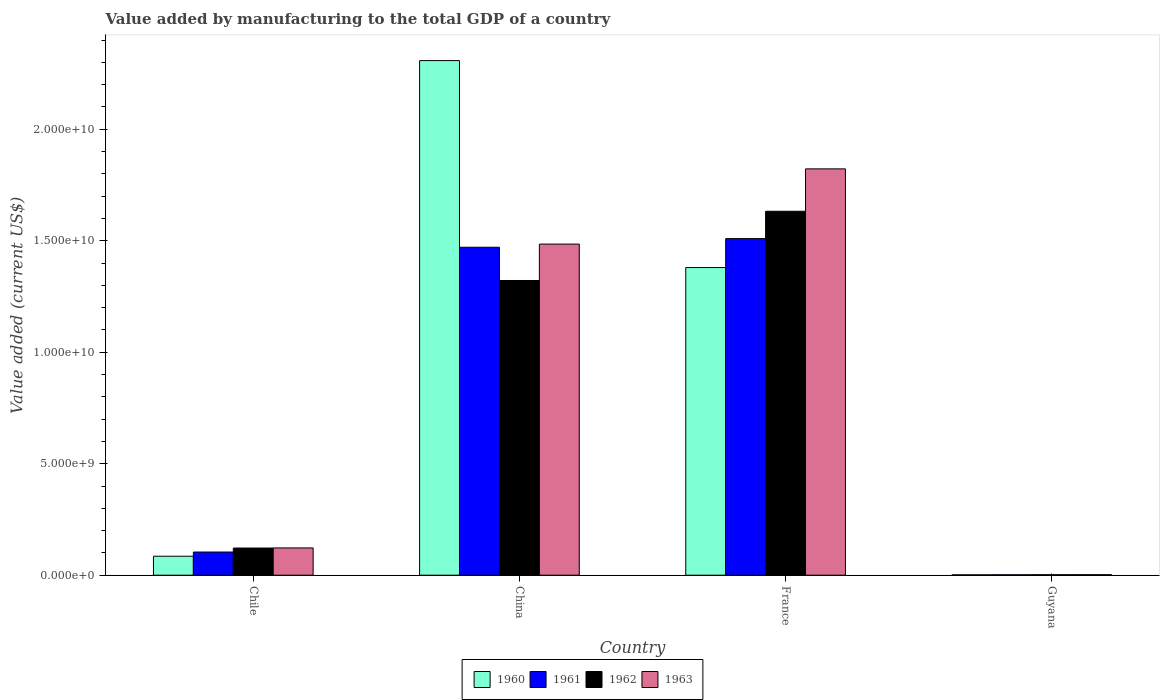How many bars are there on the 3rd tick from the left?
Your answer should be compact. 4. How many bars are there on the 1st tick from the right?
Make the answer very short. 4. In how many cases, is the number of bars for a given country not equal to the number of legend labels?
Provide a short and direct response. 0. What is the value added by manufacturing to the total GDP in 1961 in Guyana?
Keep it short and to the point. 1.84e+07. Across all countries, what is the maximum value added by manufacturing to the total GDP in 1960?
Your answer should be compact. 2.31e+1. Across all countries, what is the minimum value added by manufacturing to the total GDP in 1961?
Provide a succinct answer. 1.84e+07. In which country was the value added by manufacturing to the total GDP in 1963 minimum?
Your response must be concise. Guyana. What is the total value added by manufacturing to the total GDP in 1961 in the graph?
Offer a very short reply. 3.09e+1. What is the difference between the value added by manufacturing to the total GDP in 1962 in Chile and that in France?
Your answer should be compact. -1.51e+1. What is the difference between the value added by manufacturing to the total GDP in 1960 in France and the value added by manufacturing to the total GDP in 1962 in Guyana?
Your answer should be very brief. 1.38e+1. What is the average value added by manufacturing to the total GDP in 1963 per country?
Give a very brief answer. 8.58e+09. What is the difference between the value added by manufacturing to the total GDP of/in 1962 and value added by manufacturing to the total GDP of/in 1963 in China?
Your answer should be compact. -1.63e+09. In how many countries, is the value added by manufacturing to the total GDP in 1960 greater than 7000000000 US$?
Your answer should be very brief. 2. What is the ratio of the value added by manufacturing to the total GDP in 1962 in Chile to that in China?
Your answer should be very brief. 0.09. Is the value added by manufacturing to the total GDP in 1963 in France less than that in Guyana?
Provide a short and direct response. No. What is the difference between the highest and the second highest value added by manufacturing to the total GDP in 1960?
Ensure brevity in your answer.  1.29e+1. What is the difference between the highest and the lowest value added by manufacturing to the total GDP in 1962?
Offer a terse response. 1.63e+1. Is the sum of the value added by manufacturing to the total GDP in 1960 in Chile and France greater than the maximum value added by manufacturing to the total GDP in 1963 across all countries?
Offer a very short reply. No. What does the 4th bar from the left in China represents?
Ensure brevity in your answer.  1963. What does the 4th bar from the right in Chile represents?
Keep it short and to the point. 1960. Is it the case that in every country, the sum of the value added by manufacturing to the total GDP in 1962 and value added by manufacturing to the total GDP in 1961 is greater than the value added by manufacturing to the total GDP in 1963?
Keep it short and to the point. Yes. How many bars are there?
Offer a very short reply. 16. Are all the bars in the graph horizontal?
Give a very brief answer. No. How many countries are there in the graph?
Give a very brief answer. 4. Are the values on the major ticks of Y-axis written in scientific E-notation?
Give a very brief answer. Yes. Does the graph contain any zero values?
Your answer should be very brief. No. How are the legend labels stacked?
Offer a very short reply. Horizontal. What is the title of the graph?
Keep it short and to the point. Value added by manufacturing to the total GDP of a country. Does "1975" appear as one of the legend labels in the graph?
Keep it short and to the point. No. What is the label or title of the X-axis?
Your answer should be compact. Country. What is the label or title of the Y-axis?
Your answer should be compact. Value added (current US$). What is the Value added (current US$) in 1960 in Chile?
Offer a very short reply. 8.51e+08. What is the Value added (current US$) of 1961 in Chile?
Give a very brief answer. 1.04e+09. What is the Value added (current US$) in 1962 in Chile?
Your answer should be compact. 1.22e+09. What is the Value added (current US$) in 1963 in Chile?
Offer a very short reply. 1.22e+09. What is the Value added (current US$) in 1960 in China?
Offer a terse response. 2.31e+1. What is the Value added (current US$) of 1961 in China?
Provide a short and direct response. 1.47e+1. What is the Value added (current US$) of 1962 in China?
Offer a very short reply. 1.32e+1. What is the Value added (current US$) of 1963 in China?
Give a very brief answer. 1.49e+1. What is the Value added (current US$) in 1960 in France?
Provide a short and direct response. 1.38e+1. What is the Value added (current US$) of 1961 in France?
Give a very brief answer. 1.51e+1. What is the Value added (current US$) of 1962 in France?
Offer a terse response. 1.63e+1. What is the Value added (current US$) in 1963 in France?
Keep it short and to the point. 1.82e+1. What is the Value added (current US$) of 1960 in Guyana?
Your answer should be very brief. 1.59e+07. What is the Value added (current US$) in 1961 in Guyana?
Offer a very short reply. 1.84e+07. What is the Value added (current US$) in 1962 in Guyana?
Ensure brevity in your answer.  2.08e+07. What is the Value added (current US$) of 1963 in Guyana?
Your answer should be very brief. 2.32e+07. Across all countries, what is the maximum Value added (current US$) in 1960?
Your response must be concise. 2.31e+1. Across all countries, what is the maximum Value added (current US$) of 1961?
Keep it short and to the point. 1.51e+1. Across all countries, what is the maximum Value added (current US$) in 1962?
Provide a short and direct response. 1.63e+1. Across all countries, what is the maximum Value added (current US$) of 1963?
Ensure brevity in your answer.  1.82e+1. Across all countries, what is the minimum Value added (current US$) of 1960?
Keep it short and to the point. 1.59e+07. Across all countries, what is the minimum Value added (current US$) in 1961?
Offer a very short reply. 1.84e+07. Across all countries, what is the minimum Value added (current US$) in 1962?
Offer a very short reply. 2.08e+07. Across all countries, what is the minimum Value added (current US$) in 1963?
Keep it short and to the point. 2.32e+07. What is the total Value added (current US$) in 1960 in the graph?
Your response must be concise. 3.77e+1. What is the total Value added (current US$) of 1961 in the graph?
Your answer should be compact. 3.09e+1. What is the total Value added (current US$) of 1962 in the graph?
Offer a very short reply. 3.08e+1. What is the total Value added (current US$) in 1963 in the graph?
Provide a succinct answer. 3.43e+1. What is the difference between the Value added (current US$) in 1960 in Chile and that in China?
Make the answer very short. -2.22e+1. What is the difference between the Value added (current US$) of 1961 in Chile and that in China?
Make the answer very short. -1.37e+1. What is the difference between the Value added (current US$) in 1962 in Chile and that in China?
Offer a terse response. -1.20e+1. What is the difference between the Value added (current US$) in 1963 in Chile and that in China?
Your answer should be very brief. -1.36e+1. What is the difference between the Value added (current US$) of 1960 in Chile and that in France?
Your answer should be compact. -1.29e+1. What is the difference between the Value added (current US$) of 1961 in Chile and that in France?
Your response must be concise. -1.41e+1. What is the difference between the Value added (current US$) in 1962 in Chile and that in France?
Keep it short and to the point. -1.51e+1. What is the difference between the Value added (current US$) in 1963 in Chile and that in France?
Ensure brevity in your answer.  -1.70e+1. What is the difference between the Value added (current US$) of 1960 in Chile and that in Guyana?
Your answer should be compact. 8.35e+08. What is the difference between the Value added (current US$) in 1961 in Chile and that in Guyana?
Your answer should be compact. 1.02e+09. What is the difference between the Value added (current US$) in 1962 in Chile and that in Guyana?
Give a very brief answer. 1.20e+09. What is the difference between the Value added (current US$) in 1963 in Chile and that in Guyana?
Provide a succinct answer. 1.20e+09. What is the difference between the Value added (current US$) in 1960 in China and that in France?
Offer a terse response. 9.28e+09. What is the difference between the Value added (current US$) in 1961 in China and that in France?
Offer a terse response. -3.87e+08. What is the difference between the Value added (current US$) of 1962 in China and that in France?
Give a very brief answer. -3.11e+09. What is the difference between the Value added (current US$) in 1963 in China and that in France?
Give a very brief answer. -3.37e+09. What is the difference between the Value added (current US$) of 1960 in China and that in Guyana?
Your answer should be very brief. 2.31e+1. What is the difference between the Value added (current US$) of 1961 in China and that in Guyana?
Ensure brevity in your answer.  1.47e+1. What is the difference between the Value added (current US$) of 1962 in China and that in Guyana?
Provide a succinct answer. 1.32e+1. What is the difference between the Value added (current US$) of 1963 in China and that in Guyana?
Your answer should be very brief. 1.48e+1. What is the difference between the Value added (current US$) of 1960 in France and that in Guyana?
Offer a very short reply. 1.38e+1. What is the difference between the Value added (current US$) in 1961 in France and that in Guyana?
Offer a very short reply. 1.51e+1. What is the difference between the Value added (current US$) in 1962 in France and that in Guyana?
Your answer should be compact. 1.63e+1. What is the difference between the Value added (current US$) of 1963 in France and that in Guyana?
Your response must be concise. 1.82e+1. What is the difference between the Value added (current US$) in 1960 in Chile and the Value added (current US$) in 1961 in China?
Make the answer very short. -1.39e+1. What is the difference between the Value added (current US$) of 1960 in Chile and the Value added (current US$) of 1962 in China?
Ensure brevity in your answer.  -1.24e+1. What is the difference between the Value added (current US$) of 1960 in Chile and the Value added (current US$) of 1963 in China?
Provide a succinct answer. -1.40e+1. What is the difference between the Value added (current US$) in 1961 in Chile and the Value added (current US$) in 1962 in China?
Your answer should be compact. -1.22e+1. What is the difference between the Value added (current US$) in 1961 in Chile and the Value added (current US$) in 1963 in China?
Make the answer very short. -1.38e+1. What is the difference between the Value added (current US$) of 1962 in Chile and the Value added (current US$) of 1963 in China?
Your answer should be very brief. -1.36e+1. What is the difference between the Value added (current US$) of 1960 in Chile and the Value added (current US$) of 1961 in France?
Your response must be concise. -1.42e+1. What is the difference between the Value added (current US$) of 1960 in Chile and the Value added (current US$) of 1962 in France?
Provide a succinct answer. -1.55e+1. What is the difference between the Value added (current US$) in 1960 in Chile and the Value added (current US$) in 1963 in France?
Give a very brief answer. -1.74e+1. What is the difference between the Value added (current US$) in 1961 in Chile and the Value added (current US$) in 1962 in France?
Give a very brief answer. -1.53e+1. What is the difference between the Value added (current US$) in 1961 in Chile and the Value added (current US$) in 1963 in France?
Provide a succinct answer. -1.72e+1. What is the difference between the Value added (current US$) of 1962 in Chile and the Value added (current US$) of 1963 in France?
Give a very brief answer. -1.70e+1. What is the difference between the Value added (current US$) in 1960 in Chile and the Value added (current US$) in 1961 in Guyana?
Provide a succinct answer. 8.32e+08. What is the difference between the Value added (current US$) in 1960 in Chile and the Value added (current US$) in 1962 in Guyana?
Provide a short and direct response. 8.30e+08. What is the difference between the Value added (current US$) in 1960 in Chile and the Value added (current US$) in 1963 in Guyana?
Keep it short and to the point. 8.28e+08. What is the difference between the Value added (current US$) of 1961 in Chile and the Value added (current US$) of 1962 in Guyana?
Your answer should be compact. 1.02e+09. What is the difference between the Value added (current US$) of 1961 in Chile and the Value added (current US$) of 1963 in Guyana?
Offer a very short reply. 1.02e+09. What is the difference between the Value added (current US$) in 1962 in Chile and the Value added (current US$) in 1963 in Guyana?
Keep it short and to the point. 1.20e+09. What is the difference between the Value added (current US$) in 1960 in China and the Value added (current US$) in 1961 in France?
Your answer should be compact. 7.98e+09. What is the difference between the Value added (current US$) in 1960 in China and the Value added (current US$) in 1962 in France?
Offer a very short reply. 6.76e+09. What is the difference between the Value added (current US$) in 1960 in China and the Value added (current US$) in 1963 in France?
Keep it short and to the point. 4.86e+09. What is the difference between the Value added (current US$) of 1961 in China and the Value added (current US$) of 1962 in France?
Give a very brief answer. -1.61e+09. What is the difference between the Value added (current US$) of 1961 in China and the Value added (current US$) of 1963 in France?
Offer a terse response. -3.52e+09. What is the difference between the Value added (current US$) of 1962 in China and the Value added (current US$) of 1963 in France?
Offer a terse response. -5.01e+09. What is the difference between the Value added (current US$) of 1960 in China and the Value added (current US$) of 1961 in Guyana?
Your answer should be compact. 2.31e+1. What is the difference between the Value added (current US$) of 1960 in China and the Value added (current US$) of 1962 in Guyana?
Offer a very short reply. 2.31e+1. What is the difference between the Value added (current US$) in 1960 in China and the Value added (current US$) in 1963 in Guyana?
Provide a short and direct response. 2.31e+1. What is the difference between the Value added (current US$) in 1961 in China and the Value added (current US$) in 1962 in Guyana?
Ensure brevity in your answer.  1.47e+1. What is the difference between the Value added (current US$) of 1961 in China and the Value added (current US$) of 1963 in Guyana?
Your answer should be very brief. 1.47e+1. What is the difference between the Value added (current US$) of 1962 in China and the Value added (current US$) of 1963 in Guyana?
Your response must be concise. 1.32e+1. What is the difference between the Value added (current US$) of 1960 in France and the Value added (current US$) of 1961 in Guyana?
Offer a terse response. 1.38e+1. What is the difference between the Value added (current US$) in 1960 in France and the Value added (current US$) in 1962 in Guyana?
Provide a short and direct response. 1.38e+1. What is the difference between the Value added (current US$) in 1960 in France and the Value added (current US$) in 1963 in Guyana?
Keep it short and to the point. 1.38e+1. What is the difference between the Value added (current US$) of 1961 in France and the Value added (current US$) of 1962 in Guyana?
Your answer should be compact. 1.51e+1. What is the difference between the Value added (current US$) of 1961 in France and the Value added (current US$) of 1963 in Guyana?
Give a very brief answer. 1.51e+1. What is the difference between the Value added (current US$) of 1962 in France and the Value added (current US$) of 1963 in Guyana?
Give a very brief answer. 1.63e+1. What is the average Value added (current US$) in 1960 per country?
Your answer should be compact. 9.44e+09. What is the average Value added (current US$) in 1961 per country?
Provide a succinct answer. 7.72e+09. What is the average Value added (current US$) of 1962 per country?
Give a very brief answer. 7.70e+09. What is the average Value added (current US$) in 1963 per country?
Make the answer very short. 8.58e+09. What is the difference between the Value added (current US$) of 1960 and Value added (current US$) of 1961 in Chile?
Offer a terse response. -1.88e+08. What is the difference between the Value added (current US$) of 1960 and Value added (current US$) of 1962 in Chile?
Keep it short and to the point. -3.68e+08. What is the difference between the Value added (current US$) of 1960 and Value added (current US$) of 1963 in Chile?
Offer a terse response. -3.72e+08. What is the difference between the Value added (current US$) of 1961 and Value added (current US$) of 1962 in Chile?
Offer a very short reply. -1.80e+08. What is the difference between the Value added (current US$) in 1961 and Value added (current US$) in 1963 in Chile?
Keep it short and to the point. -1.84e+08. What is the difference between the Value added (current US$) in 1962 and Value added (current US$) in 1963 in Chile?
Give a very brief answer. -4.28e+06. What is the difference between the Value added (current US$) of 1960 and Value added (current US$) of 1961 in China?
Give a very brief answer. 8.37e+09. What is the difference between the Value added (current US$) of 1960 and Value added (current US$) of 1962 in China?
Ensure brevity in your answer.  9.86e+09. What is the difference between the Value added (current US$) in 1960 and Value added (current US$) in 1963 in China?
Give a very brief answer. 8.23e+09. What is the difference between the Value added (current US$) in 1961 and Value added (current US$) in 1962 in China?
Give a very brief answer. 1.49e+09. What is the difference between the Value added (current US$) of 1961 and Value added (current US$) of 1963 in China?
Offer a terse response. -1.42e+08. What is the difference between the Value added (current US$) in 1962 and Value added (current US$) in 1963 in China?
Provide a succinct answer. -1.63e+09. What is the difference between the Value added (current US$) of 1960 and Value added (current US$) of 1961 in France?
Provide a succinct answer. -1.30e+09. What is the difference between the Value added (current US$) of 1960 and Value added (current US$) of 1962 in France?
Offer a terse response. -2.52e+09. What is the difference between the Value added (current US$) of 1960 and Value added (current US$) of 1963 in France?
Your response must be concise. -4.43e+09. What is the difference between the Value added (current US$) in 1961 and Value added (current US$) in 1962 in France?
Keep it short and to the point. -1.23e+09. What is the difference between the Value added (current US$) in 1961 and Value added (current US$) in 1963 in France?
Give a very brief answer. -3.13e+09. What is the difference between the Value added (current US$) in 1962 and Value added (current US$) in 1963 in France?
Your response must be concise. -1.90e+09. What is the difference between the Value added (current US$) of 1960 and Value added (current US$) of 1961 in Guyana?
Provide a short and direct response. -2.51e+06. What is the difference between the Value added (current US$) in 1960 and Value added (current US$) in 1962 in Guyana?
Provide a short and direct response. -4.90e+06. What is the difference between the Value added (current US$) of 1960 and Value added (current US$) of 1963 in Guyana?
Provide a succinct answer. -7.29e+06. What is the difference between the Value added (current US$) in 1961 and Value added (current US$) in 1962 in Guyana?
Provide a short and direct response. -2.39e+06. What is the difference between the Value added (current US$) of 1961 and Value added (current US$) of 1963 in Guyana?
Make the answer very short. -4.78e+06. What is the difference between the Value added (current US$) of 1962 and Value added (current US$) of 1963 in Guyana?
Your response must be concise. -2.39e+06. What is the ratio of the Value added (current US$) in 1960 in Chile to that in China?
Give a very brief answer. 0.04. What is the ratio of the Value added (current US$) in 1961 in Chile to that in China?
Provide a short and direct response. 0.07. What is the ratio of the Value added (current US$) in 1962 in Chile to that in China?
Your answer should be very brief. 0.09. What is the ratio of the Value added (current US$) in 1963 in Chile to that in China?
Your answer should be compact. 0.08. What is the ratio of the Value added (current US$) of 1960 in Chile to that in France?
Your answer should be compact. 0.06. What is the ratio of the Value added (current US$) of 1961 in Chile to that in France?
Ensure brevity in your answer.  0.07. What is the ratio of the Value added (current US$) in 1962 in Chile to that in France?
Give a very brief answer. 0.07. What is the ratio of the Value added (current US$) in 1963 in Chile to that in France?
Offer a terse response. 0.07. What is the ratio of the Value added (current US$) of 1960 in Chile to that in Guyana?
Offer a terse response. 53.62. What is the ratio of the Value added (current US$) in 1961 in Chile to that in Guyana?
Your response must be concise. 56.53. What is the ratio of the Value added (current US$) in 1962 in Chile to that in Guyana?
Ensure brevity in your answer.  58.67. What is the ratio of the Value added (current US$) in 1963 in Chile to that in Guyana?
Give a very brief answer. 52.79. What is the ratio of the Value added (current US$) of 1960 in China to that in France?
Make the answer very short. 1.67. What is the ratio of the Value added (current US$) of 1961 in China to that in France?
Make the answer very short. 0.97. What is the ratio of the Value added (current US$) of 1962 in China to that in France?
Your response must be concise. 0.81. What is the ratio of the Value added (current US$) of 1963 in China to that in France?
Keep it short and to the point. 0.81. What is the ratio of the Value added (current US$) of 1960 in China to that in Guyana?
Provide a succinct answer. 1454.66. What is the ratio of the Value added (current US$) of 1961 in China to that in Guyana?
Offer a terse response. 800.48. What is the ratio of the Value added (current US$) of 1962 in China to that in Guyana?
Your response must be concise. 636.5. What is the ratio of the Value added (current US$) in 1963 in China to that in Guyana?
Make the answer very short. 641.28. What is the ratio of the Value added (current US$) of 1960 in France to that in Guyana?
Offer a terse response. 869.7. What is the ratio of the Value added (current US$) in 1961 in France to that in Guyana?
Provide a short and direct response. 821.55. What is the ratio of the Value added (current US$) of 1962 in France to that in Guyana?
Make the answer very short. 786.05. What is the ratio of the Value added (current US$) in 1963 in France to that in Guyana?
Give a very brief answer. 786.97. What is the difference between the highest and the second highest Value added (current US$) of 1960?
Offer a terse response. 9.28e+09. What is the difference between the highest and the second highest Value added (current US$) in 1961?
Provide a succinct answer. 3.87e+08. What is the difference between the highest and the second highest Value added (current US$) of 1962?
Provide a succinct answer. 3.11e+09. What is the difference between the highest and the second highest Value added (current US$) in 1963?
Your response must be concise. 3.37e+09. What is the difference between the highest and the lowest Value added (current US$) of 1960?
Give a very brief answer. 2.31e+1. What is the difference between the highest and the lowest Value added (current US$) of 1961?
Offer a terse response. 1.51e+1. What is the difference between the highest and the lowest Value added (current US$) of 1962?
Offer a terse response. 1.63e+1. What is the difference between the highest and the lowest Value added (current US$) in 1963?
Ensure brevity in your answer.  1.82e+1. 